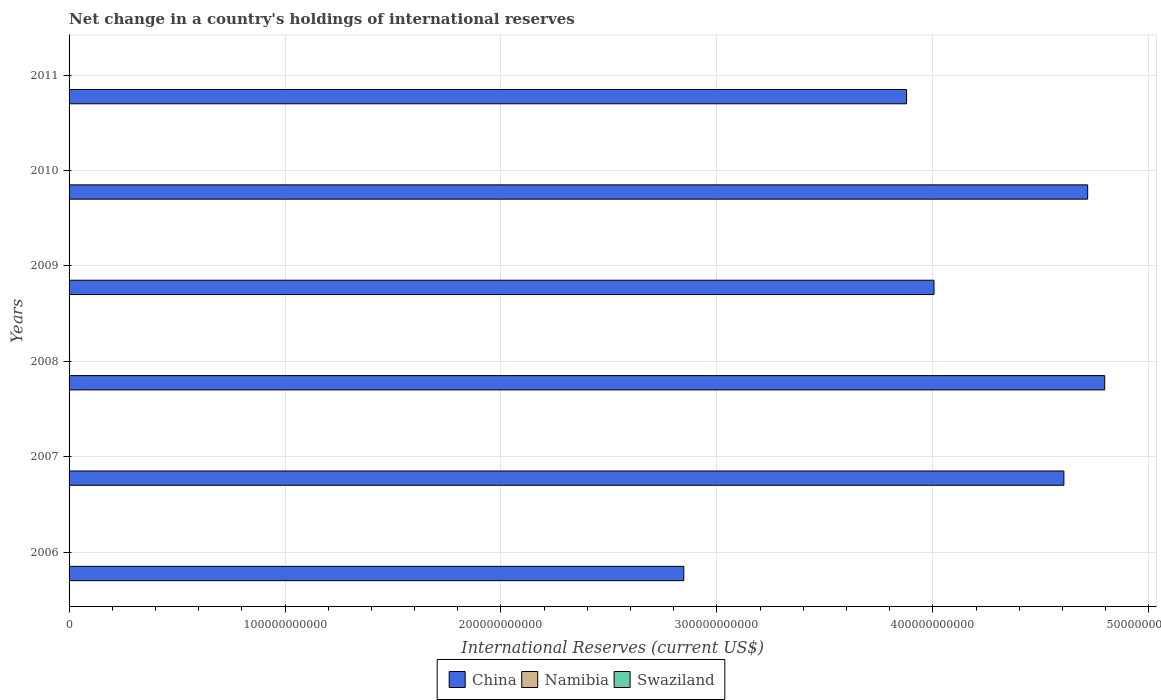How many different coloured bars are there?
Your answer should be compact. 2. Are the number of bars on each tick of the Y-axis equal?
Provide a succinct answer. No. How many bars are there on the 2nd tick from the top?
Make the answer very short. 1. In how many cases, is the number of bars for a given year not equal to the number of legend labels?
Give a very brief answer. 6. What is the international reserves in China in 2006?
Your response must be concise. 2.85e+11. Across all years, what is the maximum international reserves in Swaziland?
Provide a succinct answer. 2.20e+08. Across all years, what is the minimum international reserves in China?
Offer a very short reply. 2.85e+11. In which year was the international reserves in Swaziland maximum?
Your answer should be very brief. 2008. What is the total international reserves in Swaziland in the graph?
Ensure brevity in your answer.  2.20e+08. What is the difference between the international reserves in China in 2006 and that in 2008?
Provide a succinct answer. -1.95e+11. What is the difference between the international reserves in China in 2011 and the international reserves in Swaziland in 2008?
Offer a very short reply. 3.88e+11. What is the average international reserves in China per year?
Offer a terse response. 4.14e+11. What is the ratio of the international reserves in China in 2009 to that in 2010?
Ensure brevity in your answer.  0.85. What is the difference between the highest and the second highest international reserves in China?
Your answer should be very brief. 7.89e+09. What is the difference between the highest and the lowest international reserves in China?
Give a very brief answer. 1.95e+11. Is it the case that in every year, the sum of the international reserves in Swaziland and international reserves in China is greater than the international reserves in Namibia?
Give a very brief answer. Yes. Are all the bars in the graph horizontal?
Your answer should be compact. Yes. What is the difference between two consecutive major ticks on the X-axis?
Offer a very short reply. 1.00e+11. Does the graph contain any zero values?
Provide a short and direct response. Yes. What is the title of the graph?
Keep it short and to the point. Net change in a country's holdings of international reserves. What is the label or title of the X-axis?
Your answer should be compact. International Reserves (current US$). What is the label or title of the Y-axis?
Offer a very short reply. Years. What is the International Reserves (current US$) of China in 2006?
Offer a very short reply. 2.85e+11. What is the International Reserves (current US$) in China in 2007?
Provide a short and direct response. 4.61e+11. What is the International Reserves (current US$) in China in 2008?
Your answer should be compact. 4.80e+11. What is the International Reserves (current US$) of Swaziland in 2008?
Your answer should be compact. 2.20e+08. What is the International Reserves (current US$) of China in 2009?
Give a very brief answer. 4.01e+11. What is the International Reserves (current US$) of China in 2010?
Keep it short and to the point. 4.72e+11. What is the International Reserves (current US$) of China in 2011?
Your response must be concise. 3.88e+11. What is the International Reserves (current US$) in Namibia in 2011?
Offer a terse response. 0. Across all years, what is the maximum International Reserves (current US$) in China?
Provide a succinct answer. 4.80e+11. Across all years, what is the maximum International Reserves (current US$) of Swaziland?
Provide a short and direct response. 2.20e+08. Across all years, what is the minimum International Reserves (current US$) in China?
Provide a succinct answer. 2.85e+11. What is the total International Reserves (current US$) in China in the graph?
Your response must be concise. 2.48e+12. What is the total International Reserves (current US$) of Swaziland in the graph?
Offer a very short reply. 2.20e+08. What is the difference between the International Reserves (current US$) of China in 2006 and that in 2007?
Keep it short and to the point. -1.76e+11. What is the difference between the International Reserves (current US$) in China in 2006 and that in 2008?
Your answer should be very brief. -1.95e+11. What is the difference between the International Reserves (current US$) of China in 2006 and that in 2009?
Keep it short and to the point. -1.16e+11. What is the difference between the International Reserves (current US$) in China in 2006 and that in 2010?
Provide a short and direct response. -1.87e+11. What is the difference between the International Reserves (current US$) of China in 2006 and that in 2011?
Make the answer very short. -1.03e+11. What is the difference between the International Reserves (current US$) in China in 2007 and that in 2008?
Offer a terse response. -1.89e+1. What is the difference between the International Reserves (current US$) of China in 2007 and that in 2009?
Provide a succinct answer. 6.01e+1. What is the difference between the International Reserves (current US$) in China in 2007 and that in 2010?
Offer a terse response. -1.10e+1. What is the difference between the International Reserves (current US$) of China in 2007 and that in 2011?
Your response must be concise. 7.29e+1. What is the difference between the International Reserves (current US$) of China in 2008 and that in 2009?
Offer a very short reply. 7.90e+1. What is the difference between the International Reserves (current US$) in China in 2008 and that in 2010?
Offer a terse response. 7.89e+09. What is the difference between the International Reserves (current US$) of China in 2008 and that in 2011?
Provide a short and direct response. 9.18e+1. What is the difference between the International Reserves (current US$) of China in 2009 and that in 2010?
Give a very brief answer. -7.12e+1. What is the difference between the International Reserves (current US$) of China in 2009 and that in 2011?
Keep it short and to the point. 1.27e+1. What is the difference between the International Reserves (current US$) in China in 2010 and that in 2011?
Ensure brevity in your answer.  8.39e+1. What is the difference between the International Reserves (current US$) of China in 2006 and the International Reserves (current US$) of Swaziland in 2008?
Give a very brief answer. 2.84e+11. What is the difference between the International Reserves (current US$) in China in 2007 and the International Reserves (current US$) in Swaziland in 2008?
Give a very brief answer. 4.60e+11. What is the average International Reserves (current US$) of China per year?
Make the answer very short. 4.14e+11. What is the average International Reserves (current US$) of Swaziland per year?
Your answer should be very brief. 3.66e+07. In the year 2008, what is the difference between the International Reserves (current US$) of China and International Reserves (current US$) of Swaziland?
Your response must be concise. 4.79e+11. What is the ratio of the International Reserves (current US$) in China in 2006 to that in 2007?
Offer a very short reply. 0.62. What is the ratio of the International Reserves (current US$) in China in 2006 to that in 2008?
Offer a very short reply. 0.59. What is the ratio of the International Reserves (current US$) of China in 2006 to that in 2009?
Make the answer very short. 0.71. What is the ratio of the International Reserves (current US$) of China in 2006 to that in 2010?
Make the answer very short. 0.6. What is the ratio of the International Reserves (current US$) in China in 2006 to that in 2011?
Make the answer very short. 0.73. What is the ratio of the International Reserves (current US$) in China in 2007 to that in 2008?
Keep it short and to the point. 0.96. What is the ratio of the International Reserves (current US$) in China in 2007 to that in 2009?
Make the answer very short. 1.15. What is the ratio of the International Reserves (current US$) of China in 2007 to that in 2010?
Provide a succinct answer. 0.98. What is the ratio of the International Reserves (current US$) in China in 2007 to that in 2011?
Ensure brevity in your answer.  1.19. What is the ratio of the International Reserves (current US$) of China in 2008 to that in 2009?
Provide a short and direct response. 1.2. What is the ratio of the International Reserves (current US$) of China in 2008 to that in 2010?
Ensure brevity in your answer.  1.02. What is the ratio of the International Reserves (current US$) in China in 2008 to that in 2011?
Offer a very short reply. 1.24. What is the ratio of the International Reserves (current US$) of China in 2009 to that in 2010?
Keep it short and to the point. 0.85. What is the ratio of the International Reserves (current US$) in China in 2009 to that in 2011?
Offer a very short reply. 1.03. What is the ratio of the International Reserves (current US$) of China in 2010 to that in 2011?
Keep it short and to the point. 1.22. What is the difference between the highest and the second highest International Reserves (current US$) of China?
Give a very brief answer. 7.89e+09. What is the difference between the highest and the lowest International Reserves (current US$) in China?
Provide a succinct answer. 1.95e+11. What is the difference between the highest and the lowest International Reserves (current US$) of Swaziland?
Provide a succinct answer. 2.20e+08. 